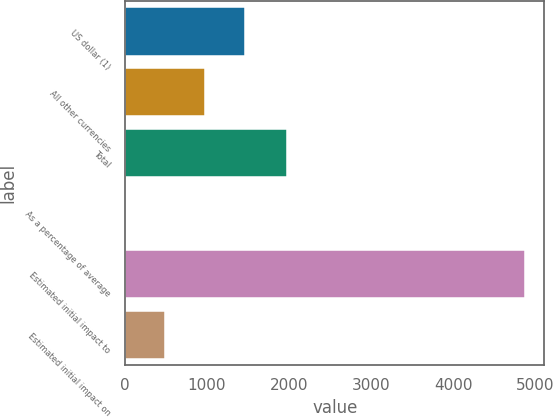Convert chart. <chart><loc_0><loc_0><loc_500><loc_500><bar_chart><fcel>US dollar (1)<fcel>All other currencies<fcel>Total<fcel>As a percentage of average<fcel>Estimated initial impact to<fcel>Estimated initial impact on<nl><fcel>1460.49<fcel>973.7<fcel>1979<fcel>0.12<fcel>4868<fcel>486.91<nl></chart> 